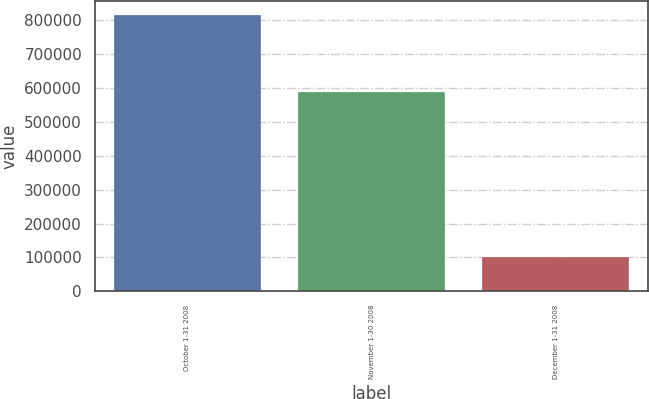Convert chart. <chart><loc_0><loc_0><loc_500><loc_500><bar_chart><fcel>October 1-31 2008<fcel>November 1-30 2008<fcel>December 1-31 2008<nl><fcel>816284<fcel>588721<fcel>100661<nl></chart> 